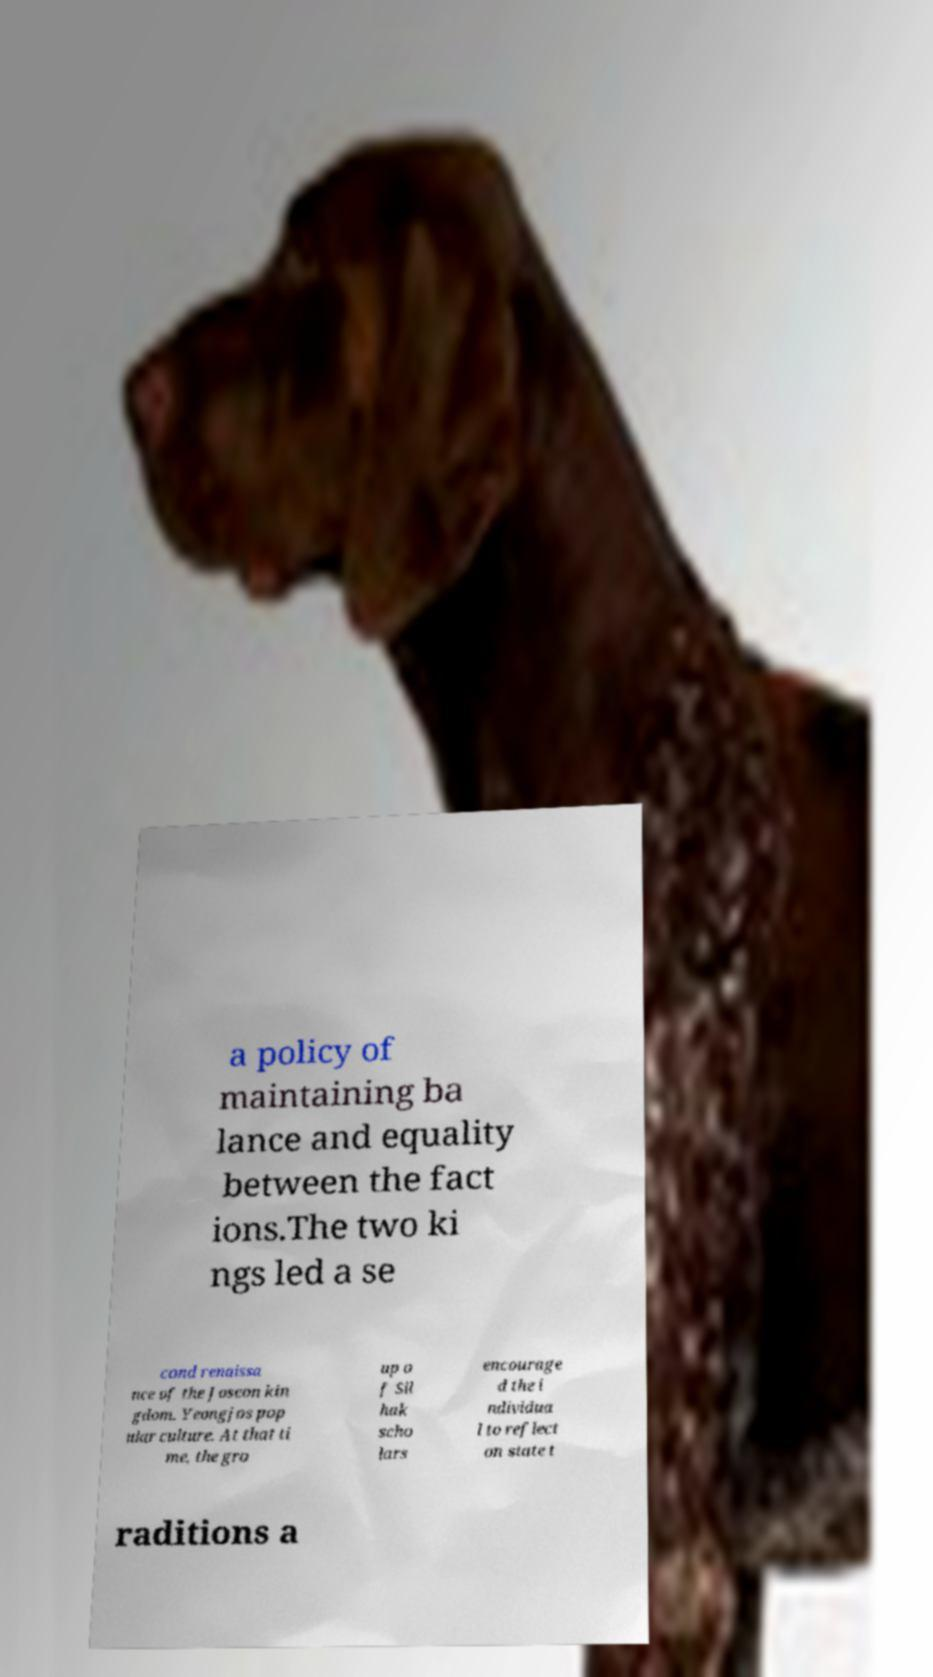Could you assist in decoding the text presented in this image and type it out clearly? a policy of maintaining ba lance and equality between the fact ions.The two ki ngs led a se cond renaissa nce of the Joseon kin gdom. Yeongjos pop ular culture. At that ti me, the gro up o f Sil hak scho lars encourage d the i ndividua l to reflect on state t raditions a 